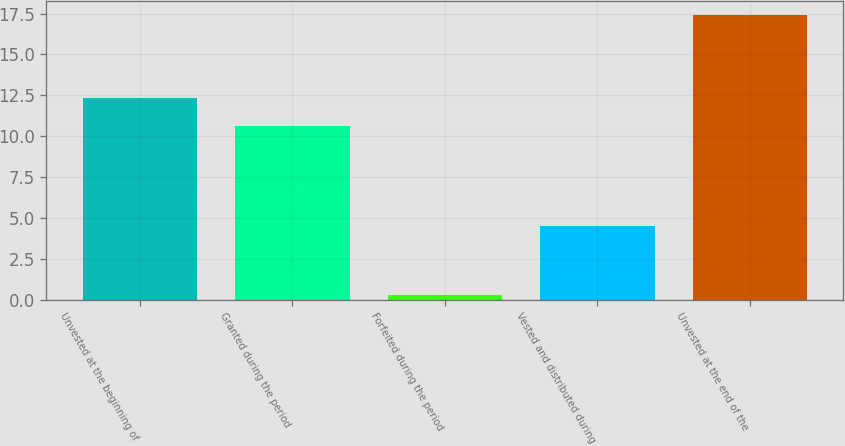<chart> <loc_0><loc_0><loc_500><loc_500><bar_chart><fcel>Unvested at the beginning of<fcel>Granted during the period<fcel>Forfeited during the period<fcel>Vested and distributed during<fcel>Unvested at the end of the<nl><fcel>12.31<fcel>10.6<fcel>0.3<fcel>4.5<fcel>17.4<nl></chart> 